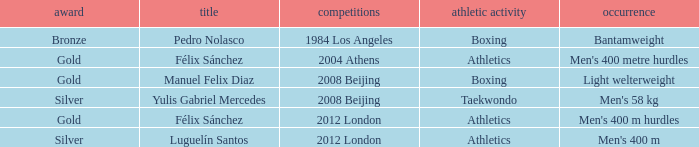Which Sport had an Event of men's 400 m hurdles? Athletics. 